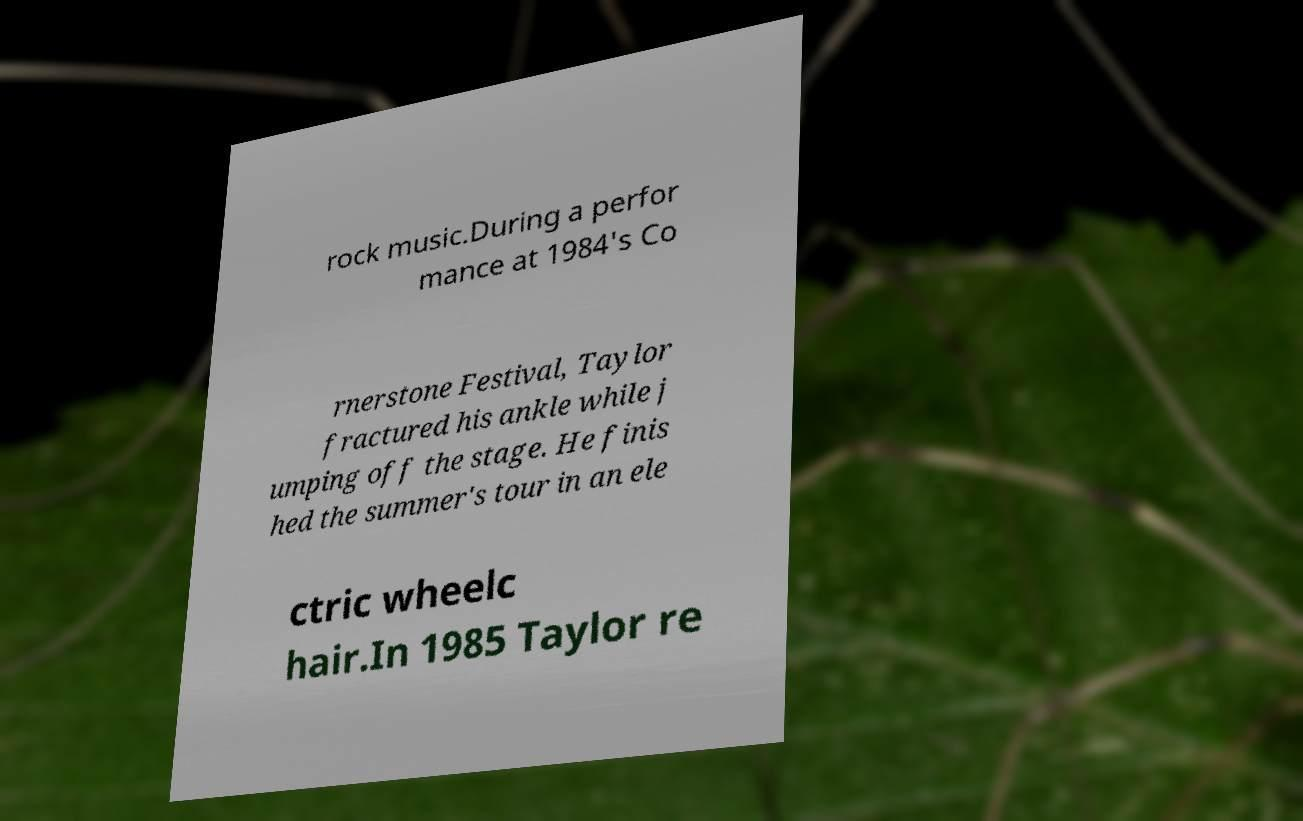Could you extract and type out the text from this image? rock music.During a perfor mance at 1984's Co rnerstone Festival, Taylor fractured his ankle while j umping off the stage. He finis hed the summer's tour in an ele ctric wheelc hair.In 1985 Taylor re 